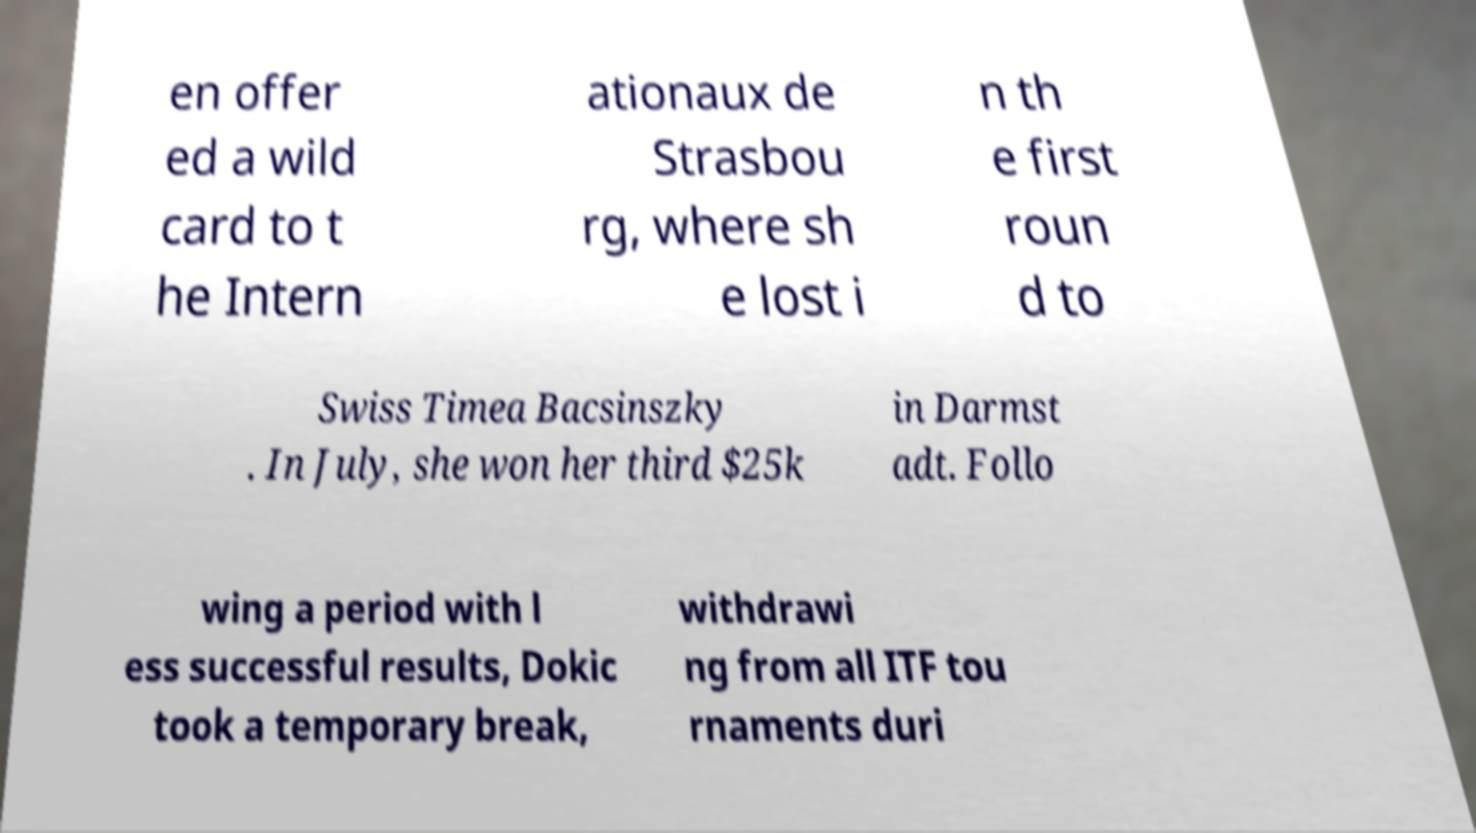I need the written content from this picture converted into text. Can you do that? en offer ed a wild card to t he Intern ationaux de Strasbou rg, where sh e lost i n th e first roun d to Swiss Timea Bacsinszky . In July, she won her third $25k in Darmst adt. Follo wing a period with l ess successful results, Dokic took a temporary break, withdrawi ng from all ITF tou rnaments duri 